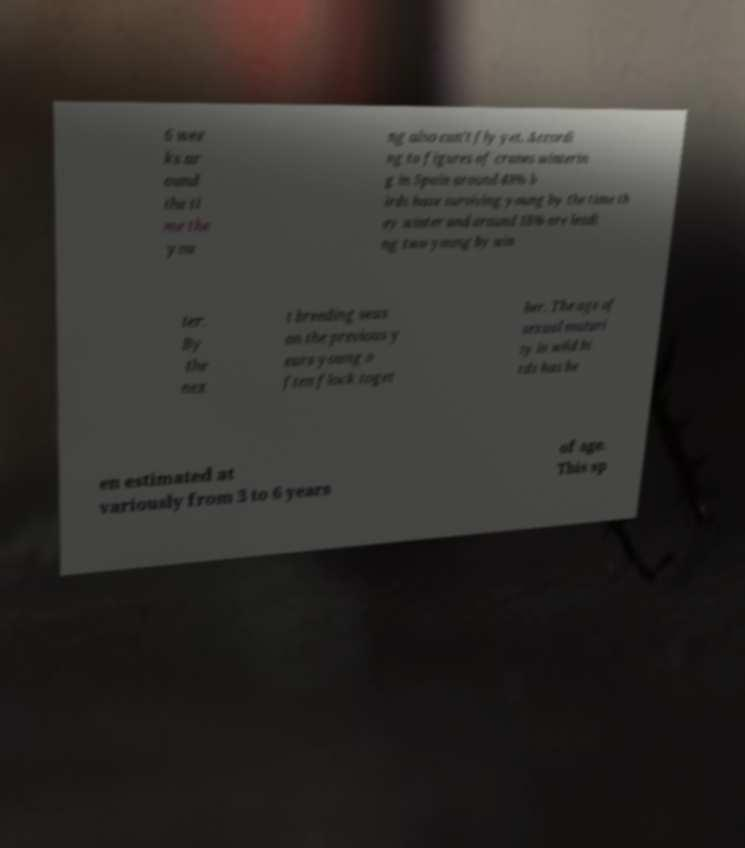Could you extract and type out the text from this image? 6 wee ks ar ound the ti me the you ng also can't fly yet. Accordi ng to figures of cranes winterin g in Spain around 48% b irds have surviving young by the time th ey winter and around 18% are leadi ng two young by win ter. By the nex t breeding seas on the previous y ears young o ften flock toget her. The age of sexual maturi ty in wild bi rds has be en estimated at variously from 3 to 6 years of age. This sp 